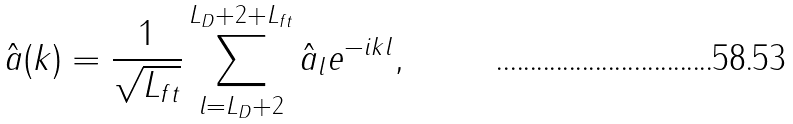<formula> <loc_0><loc_0><loc_500><loc_500>\hat { a } ( k ) = \frac { 1 } { \sqrt { L _ { f t } } } \sum _ { l = L _ { D } + 2 } ^ { L _ { D } + 2 + L _ { f t } } \hat { a } _ { l } e ^ { - i k l } ,</formula> 